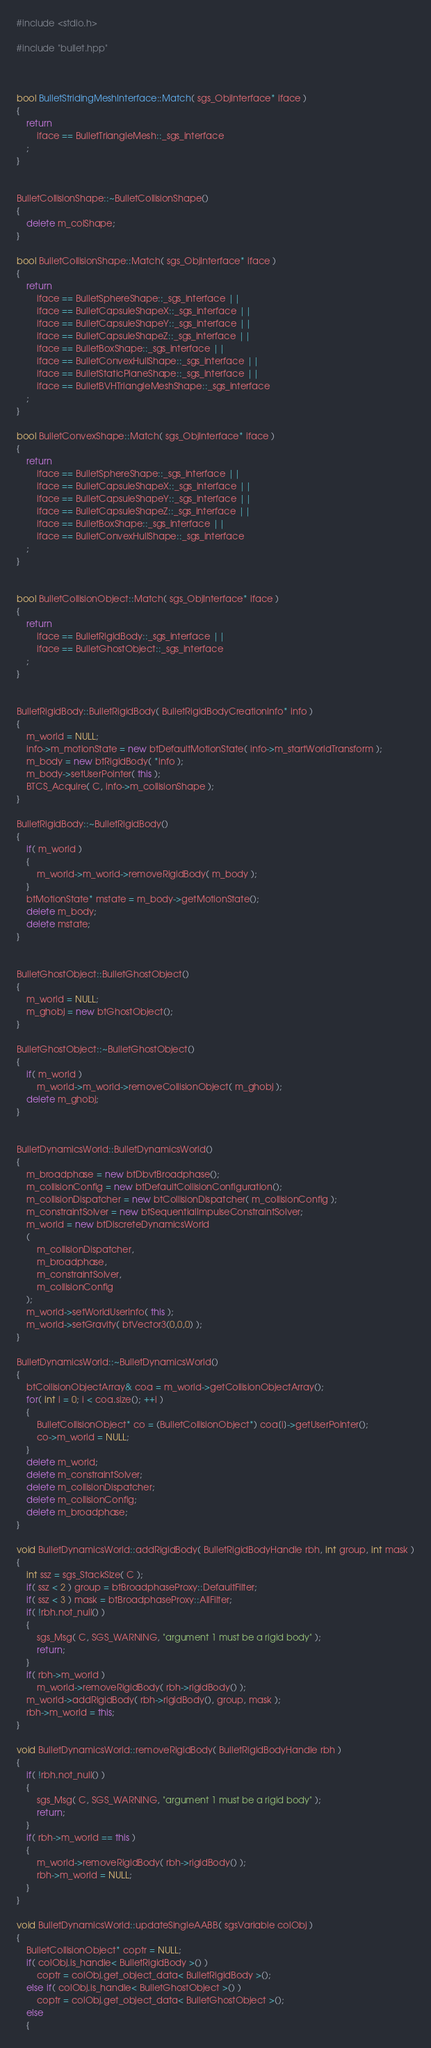Convert code to text. <code><loc_0><loc_0><loc_500><loc_500><_C++_>

#include <stdio.h>

#include "bullet.hpp"



bool BulletStridingMeshInterface::Match( sgs_ObjInterface* iface )
{
	return
		iface == BulletTriangleMesh::_sgs_interface
	;
}


BulletCollisionShape::~BulletCollisionShape()
{
	delete m_colShape;
}

bool BulletCollisionShape::Match( sgs_ObjInterface* iface )
{
	return
		iface == BulletSphereShape::_sgs_interface ||
		iface == BulletCapsuleShapeX::_sgs_interface ||
		iface == BulletCapsuleShapeY::_sgs_interface ||
		iface == BulletCapsuleShapeZ::_sgs_interface ||
		iface == BulletBoxShape::_sgs_interface ||
		iface == BulletConvexHullShape::_sgs_interface ||
		iface == BulletStaticPlaneShape::_sgs_interface ||
		iface == BulletBVHTriangleMeshShape::_sgs_interface
	;
}

bool BulletConvexShape::Match( sgs_ObjInterface* iface )
{
	return
		iface == BulletSphereShape::_sgs_interface ||
		iface == BulletCapsuleShapeX::_sgs_interface ||
		iface == BulletCapsuleShapeY::_sgs_interface ||
		iface == BulletCapsuleShapeZ::_sgs_interface ||
		iface == BulletBoxShape::_sgs_interface ||
		iface == BulletConvexHullShape::_sgs_interface
	;
}


bool BulletCollisionObject::Match( sgs_ObjInterface* iface )
{
	return
		iface == BulletRigidBody::_sgs_interface ||
		iface == BulletGhostObject::_sgs_interface
	;
}


BulletRigidBody::BulletRigidBody( BulletRigidBodyCreationInfo* info )
{
	m_world = NULL;
	info->m_motionState = new btDefaultMotionState( info->m_startWorldTransform );
	m_body = new btRigidBody( *info );
	m_body->setUserPointer( this );
	BTCS_Acquire( C, info->m_collisionShape );
}

BulletRigidBody::~BulletRigidBody()
{
	if( m_world )
	{
		m_world->m_world->removeRigidBody( m_body );
	}
	btMotionState* mstate = m_body->getMotionState();
	delete m_body;
	delete mstate;
}


BulletGhostObject::BulletGhostObject()
{
	m_world = NULL;
	m_ghobj = new btGhostObject();
}

BulletGhostObject::~BulletGhostObject()
{
	if( m_world )
		m_world->m_world->removeCollisionObject( m_ghobj );
	delete m_ghobj;
}


BulletDynamicsWorld::BulletDynamicsWorld()
{
	m_broadphase = new btDbvtBroadphase();
	m_collisionConfig = new btDefaultCollisionConfiguration();
	m_collisionDispatcher = new btCollisionDispatcher( m_collisionConfig );
	m_constraintSolver = new btSequentialImpulseConstraintSolver;
	m_world = new btDiscreteDynamicsWorld
	(
		m_collisionDispatcher,
		m_broadphase,
		m_constraintSolver,
		m_collisionConfig
	);
	m_world->setWorldUserInfo( this );
	m_world->setGravity( btVector3(0,0,0) );
}

BulletDynamicsWorld::~BulletDynamicsWorld()
{
	btCollisionObjectArray& coa = m_world->getCollisionObjectArray();
	for( int i = 0; i < coa.size(); ++i )
	{
		BulletCollisionObject* co = (BulletCollisionObject*) coa[i]->getUserPointer();
		co->m_world = NULL;
	}
	delete m_world;
	delete m_constraintSolver;
	delete m_collisionDispatcher;
	delete m_collisionConfig;
	delete m_broadphase;
}

void BulletDynamicsWorld::addRigidBody( BulletRigidBodyHandle rbh, int group, int mask )
{
	int ssz = sgs_StackSize( C );
	if( ssz < 2 ) group = btBroadphaseProxy::DefaultFilter;
	if( ssz < 3 ) mask = btBroadphaseProxy::AllFilter;
	if( !rbh.not_null() )
	{
		sgs_Msg( C, SGS_WARNING, "argument 1 must be a rigid body" );
		return;
	}
	if( rbh->m_world )
		m_world->removeRigidBody( rbh->rigidBody() );
	m_world->addRigidBody( rbh->rigidBody(), group, mask );
	rbh->m_world = this;
}

void BulletDynamicsWorld::removeRigidBody( BulletRigidBodyHandle rbh )
{
	if( !rbh.not_null() )
	{
		sgs_Msg( C, SGS_WARNING, "argument 1 must be a rigid body" );
		return;
	}
	if( rbh->m_world == this )
	{
		m_world->removeRigidBody( rbh->rigidBody() );
		rbh->m_world = NULL;
	}
}

void BulletDynamicsWorld::updateSingleAABB( sgsVariable colObj )
{
	BulletCollisionObject* coptr = NULL;
	if( colObj.is_handle< BulletRigidBody >() )
		coptr = colObj.get_object_data< BulletRigidBody >();
	else if( colObj.is_handle< BulletGhostObject >() )
		coptr = colObj.get_object_data< BulletGhostObject >();
	else
	{</code> 